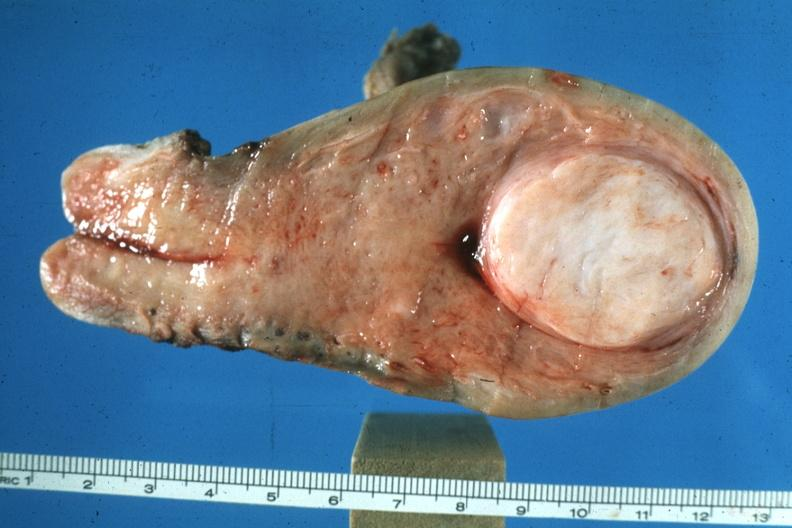s uterus present?
Answer the question using a single word or phrase. Yes 